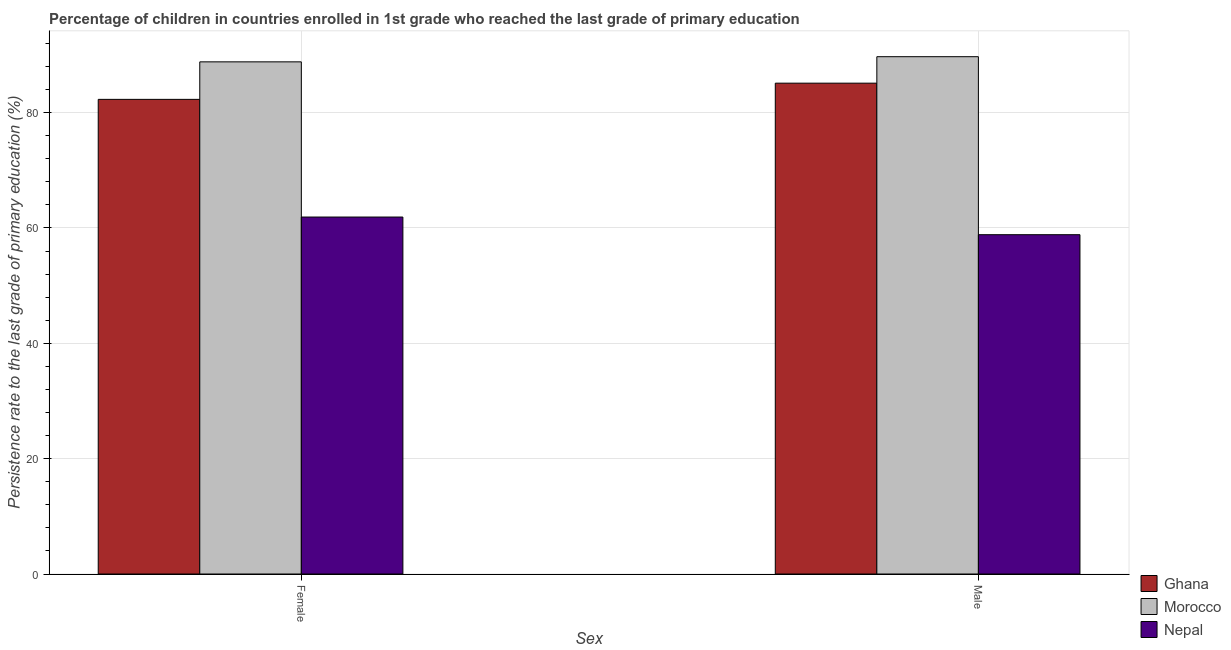Are the number of bars per tick equal to the number of legend labels?
Provide a succinct answer. Yes. How many bars are there on the 1st tick from the left?
Provide a succinct answer. 3. What is the persistence rate of male students in Ghana?
Give a very brief answer. 85.1. Across all countries, what is the maximum persistence rate of male students?
Keep it short and to the point. 89.69. Across all countries, what is the minimum persistence rate of male students?
Keep it short and to the point. 58.83. In which country was the persistence rate of female students maximum?
Give a very brief answer. Morocco. In which country was the persistence rate of male students minimum?
Provide a succinct answer. Nepal. What is the total persistence rate of female students in the graph?
Provide a short and direct response. 232.97. What is the difference between the persistence rate of male students in Ghana and that in Morocco?
Make the answer very short. -4.59. What is the difference between the persistence rate of male students in Morocco and the persistence rate of female students in Ghana?
Your answer should be compact. 7.4. What is the average persistence rate of female students per country?
Keep it short and to the point. 77.66. What is the difference between the persistence rate of male students and persistence rate of female students in Nepal?
Your answer should be compact. -3.06. In how many countries, is the persistence rate of male students greater than 32 %?
Provide a short and direct response. 3. What is the ratio of the persistence rate of female students in Morocco to that in Nepal?
Your response must be concise. 1.43. Is the persistence rate of female students in Ghana less than that in Morocco?
Give a very brief answer. Yes. What does the 3rd bar from the left in Female represents?
Provide a short and direct response. Nepal. What does the 1st bar from the right in Female represents?
Provide a short and direct response. Nepal. What is the difference between two consecutive major ticks on the Y-axis?
Ensure brevity in your answer.  20. Are the values on the major ticks of Y-axis written in scientific E-notation?
Make the answer very short. No. Does the graph contain any zero values?
Make the answer very short. No. Does the graph contain grids?
Keep it short and to the point. Yes. How many legend labels are there?
Your answer should be very brief. 3. How are the legend labels stacked?
Make the answer very short. Vertical. What is the title of the graph?
Provide a succinct answer. Percentage of children in countries enrolled in 1st grade who reached the last grade of primary education. What is the label or title of the X-axis?
Ensure brevity in your answer.  Sex. What is the label or title of the Y-axis?
Your answer should be compact. Persistence rate to the last grade of primary education (%). What is the Persistence rate to the last grade of primary education (%) in Ghana in Female?
Make the answer very short. 82.29. What is the Persistence rate to the last grade of primary education (%) of Morocco in Female?
Offer a terse response. 88.79. What is the Persistence rate to the last grade of primary education (%) of Nepal in Female?
Keep it short and to the point. 61.89. What is the Persistence rate to the last grade of primary education (%) of Ghana in Male?
Give a very brief answer. 85.1. What is the Persistence rate to the last grade of primary education (%) in Morocco in Male?
Your answer should be compact. 89.69. What is the Persistence rate to the last grade of primary education (%) of Nepal in Male?
Your response must be concise. 58.83. Across all Sex, what is the maximum Persistence rate to the last grade of primary education (%) in Ghana?
Offer a terse response. 85.1. Across all Sex, what is the maximum Persistence rate to the last grade of primary education (%) of Morocco?
Provide a short and direct response. 89.69. Across all Sex, what is the maximum Persistence rate to the last grade of primary education (%) in Nepal?
Keep it short and to the point. 61.89. Across all Sex, what is the minimum Persistence rate to the last grade of primary education (%) of Ghana?
Give a very brief answer. 82.29. Across all Sex, what is the minimum Persistence rate to the last grade of primary education (%) of Morocco?
Offer a terse response. 88.79. Across all Sex, what is the minimum Persistence rate to the last grade of primary education (%) of Nepal?
Your response must be concise. 58.83. What is the total Persistence rate to the last grade of primary education (%) of Ghana in the graph?
Offer a very short reply. 167.39. What is the total Persistence rate to the last grade of primary education (%) of Morocco in the graph?
Make the answer very short. 178.48. What is the total Persistence rate to the last grade of primary education (%) in Nepal in the graph?
Ensure brevity in your answer.  120.72. What is the difference between the Persistence rate to the last grade of primary education (%) in Ghana in Female and that in Male?
Offer a terse response. -2.81. What is the difference between the Persistence rate to the last grade of primary education (%) in Morocco in Female and that in Male?
Provide a short and direct response. -0.9. What is the difference between the Persistence rate to the last grade of primary education (%) of Nepal in Female and that in Male?
Ensure brevity in your answer.  3.06. What is the difference between the Persistence rate to the last grade of primary education (%) in Ghana in Female and the Persistence rate to the last grade of primary education (%) in Morocco in Male?
Offer a very short reply. -7.4. What is the difference between the Persistence rate to the last grade of primary education (%) in Ghana in Female and the Persistence rate to the last grade of primary education (%) in Nepal in Male?
Provide a short and direct response. 23.46. What is the difference between the Persistence rate to the last grade of primary education (%) in Morocco in Female and the Persistence rate to the last grade of primary education (%) in Nepal in Male?
Keep it short and to the point. 29.97. What is the average Persistence rate to the last grade of primary education (%) in Ghana per Sex?
Your answer should be compact. 83.69. What is the average Persistence rate to the last grade of primary education (%) in Morocco per Sex?
Provide a succinct answer. 89.24. What is the average Persistence rate to the last grade of primary education (%) of Nepal per Sex?
Keep it short and to the point. 60.36. What is the difference between the Persistence rate to the last grade of primary education (%) in Ghana and Persistence rate to the last grade of primary education (%) in Morocco in Female?
Your answer should be compact. -6.5. What is the difference between the Persistence rate to the last grade of primary education (%) in Ghana and Persistence rate to the last grade of primary education (%) in Nepal in Female?
Offer a very short reply. 20.4. What is the difference between the Persistence rate to the last grade of primary education (%) in Morocco and Persistence rate to the last grade of primary education (%) in Nepal in Female?
Offer a terse response. 26.9. What is the difference between the Persistence rate to the last grade of primary education (%) of Ghana and Persistence rate to the last grade of primary education (%) of Morocco in Male?
Make the answer very short. -4.59. What is the difference between the Persistence rate to the last grade of primary education (%) in Ghana and Persistence rate to the last grade of primary education (%) in Nepal in Male?
Make the answer very short. 26.27. What is the difference between the Persistence rate to the last grade of primary education (%) in Morocco and Persistence rate to the last grade of primary education (%) in Nepal in Male?
Ensure brevity in your answer.  30.86. What is the ratio of the Persistence rate to the last grade of primary education (%) in Ghana in Female to that in Male?
Make the answer very short. 0.97. What is the ratio of the Persistence rate to the last grade of primary education (%) in Morocco in Female to that in Male?
Make the answer very short. 0.99. What is the ratio of the Persistence rate to the last grade of primary education (%) in Nepal in Female to that in Male?
Keep it short and to the point. 1.05. What is the difference between the highest and the second highest Persistence rate to the last grade of primary education (%) of Ghana?
Make the answer very short. 2.81. What is the difference between the highest and the second highest Persistence rate to the last grade of primary education (%) in Morocco?
Ensure brevity in your answer.  0.9. What is the difference between the highest and the second highest Persistence rate to the last grade of primary education (%) of Nepal?
Ensure brevity in your answer.  3.06. What is the difference between the highest and the lowest Persistence rate to the last grade of primary education (%) in Ghana?
Provide a succinct answer. 2.81. What is the difference between the highest and the lowest Persistence rate to the last grade of primary education (%) of Morocco?
Provide a succinct answer. 0.9. What is the difference between the highest and the lowest Persistence rate to the last grade of primary education (%) in Nepal?
Keep it short and to the point. 3.06. 